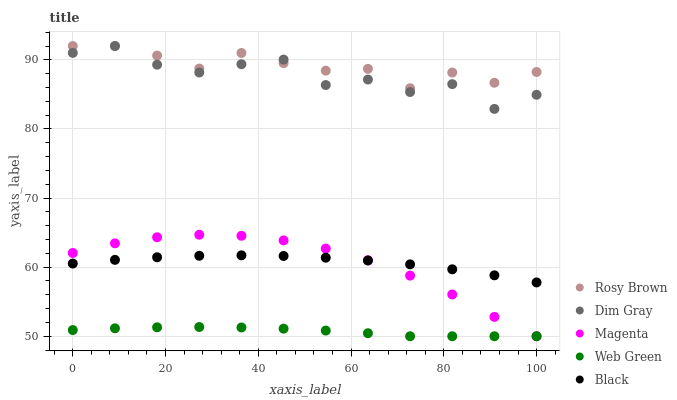Does Web Green have the minimum area under the curve?
Answer yes or no. Yes. Does Rosy Brown have the maximum area under the curve?
Answer yes or no. Yes. Does Black have the minimum area under the curve?
Answer yes or no. No. Does Black have the maximum area under the curve?
Answer yes or no. No. Is Web Green the smoothest?
Answer yes or no. Yes. Is Dim Gray the roughest?
Answer yes or no. Yes. Is Rosy Brown the smoothest?
Answer yes or no. No. Is Rosy Brown the roughest?
Answer yes or no. No. Does Magenta have the lowest value?
Answer yes or no. Yes. Does Black have the lowest value?
Answer yes or no. No. Does Rosy Brown have the highest value?
Answer yes or no. Yes. Does Black have the highest value?
Answer yes or no. No. Is Magenta less than Rosy Brown?
Answer yes or no. Yes. Is Rosy Brown greater than Magenta?
Answer yes or no. Yes. Does Dim Gray intersect Rosy Brown?
Answer yes or no. Yes. Is Dim Gray less than Rosy Brown?
Answer yes or no. No. Is Dim Gray greater than Rosy Brown?
Answer yes or no. No. Does Magenta intersect Rosy Brown?
Answer yes or no. No. 